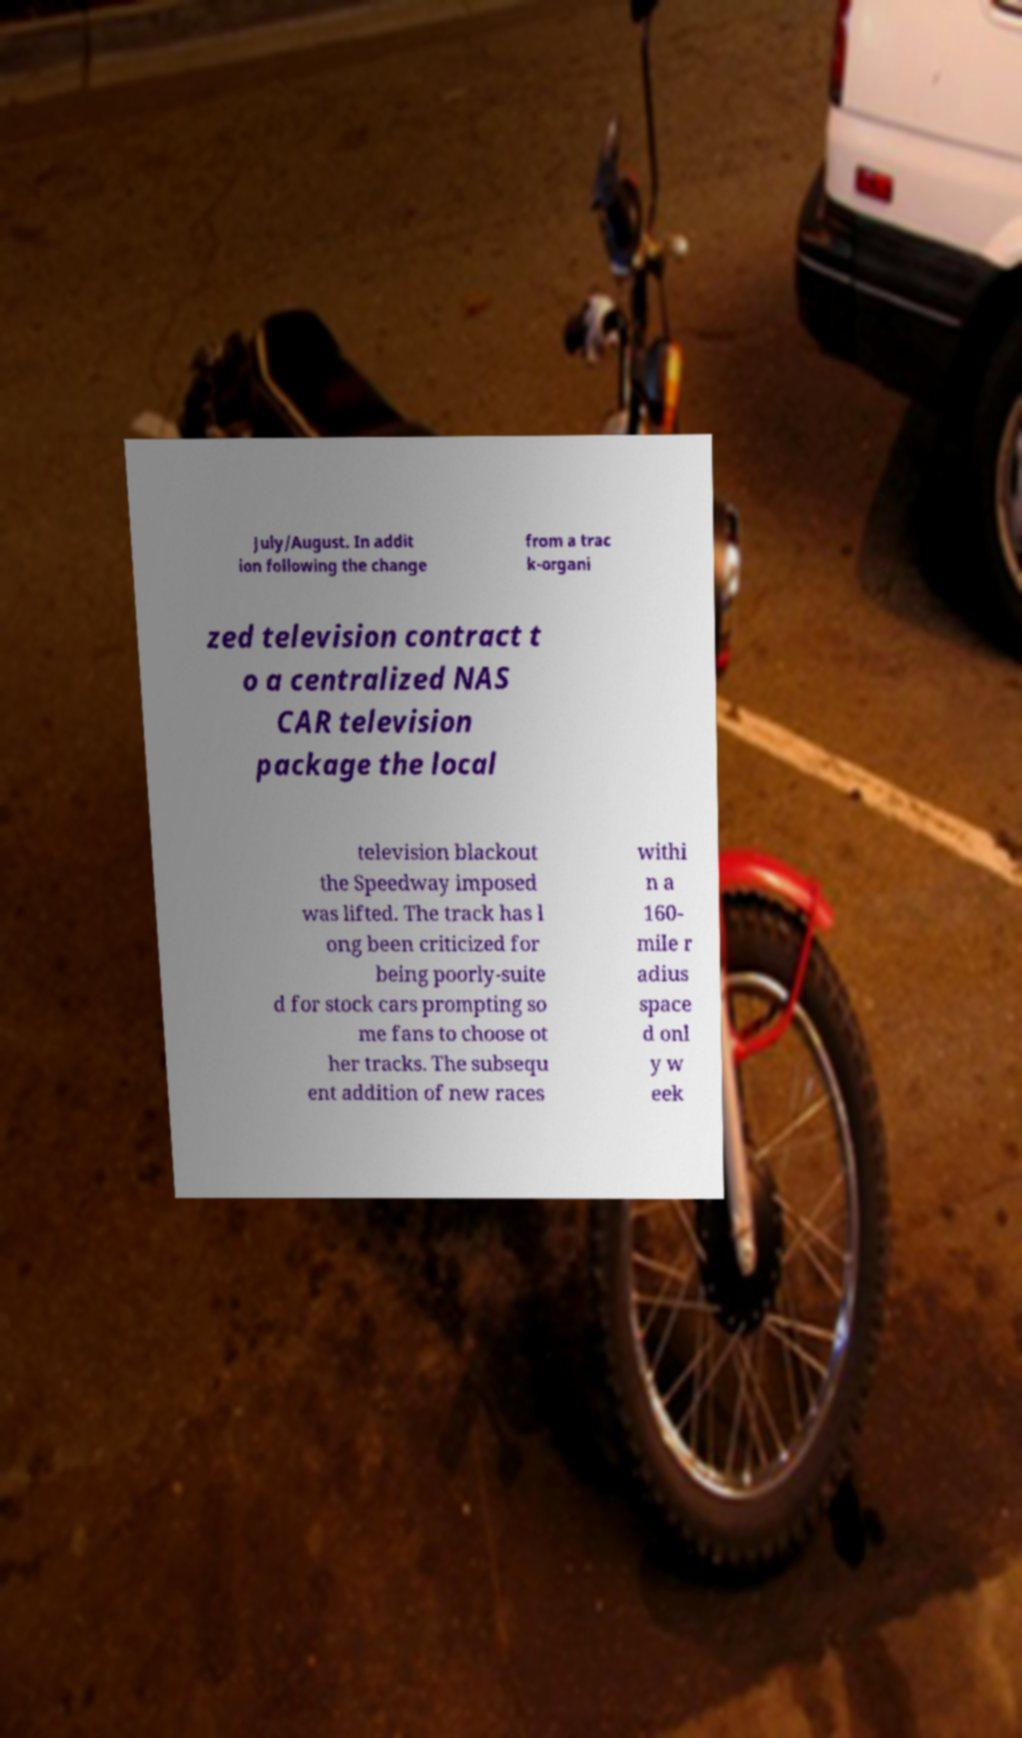What messages or text are displayed in this image? I need them in a readable, typed format. July/August. In addit ion following the change from a trac k-organi zed television contract t o a centralized NAS CAR television package the local television blackout the Speedway imposed was lifted. The track has l ong been criticized for being poorly-suite d for stock cars prompting so me fans to choose ot her tracks. The subsequ ent addition of new races withi n a 160- mile r adius space d onl y w eek 